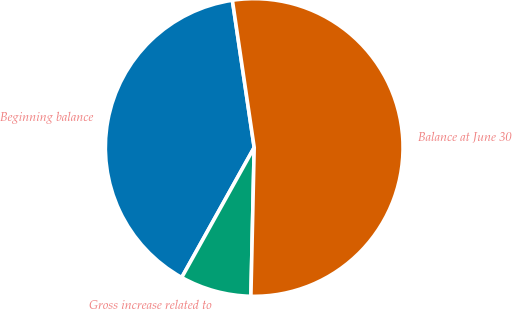<chart> <loc_0><loc_0><loc_500><loc_500><pie_chart><fcel>Beginning balance<fcel>Gross increase related to<fcel>Balance at June 30<nl><fcel>39.56%<fcel>7.74%<fcel>52.69%<nl></chart> 